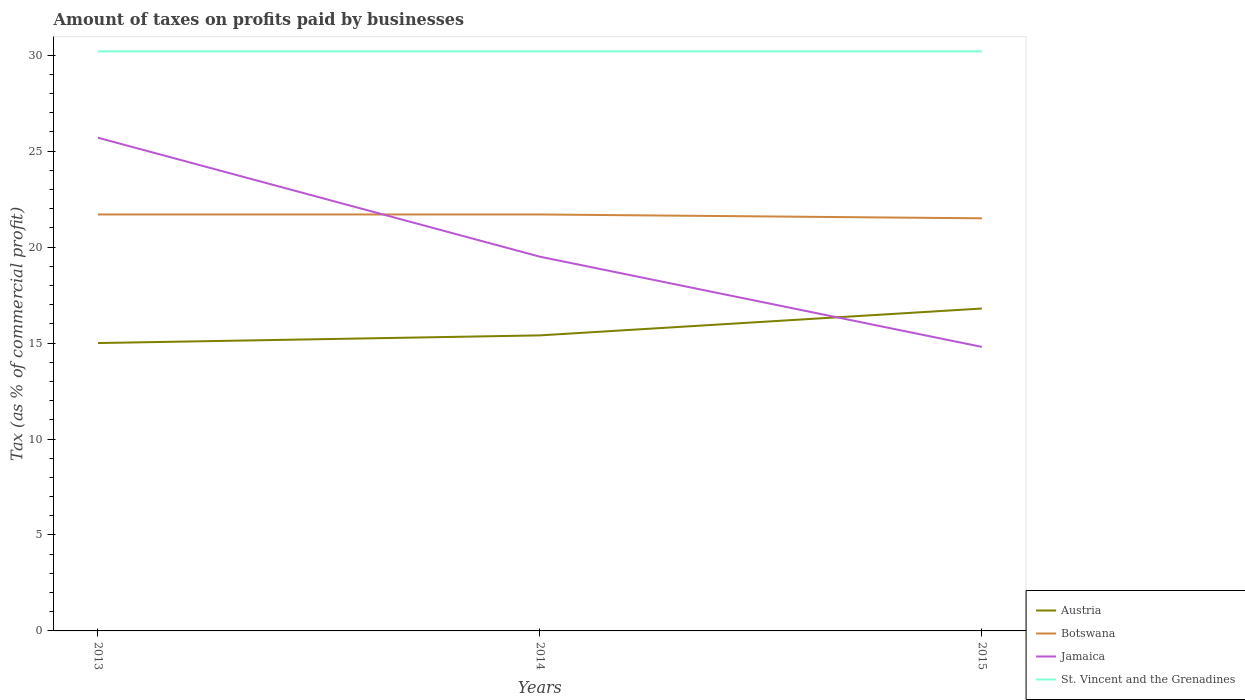Does the line corresponding to St. Vincent and the Grenadines intersect with the line corresponding to Botswana?
Make the answer very short. No. Across all years, what is the maximum percentage of taxes paid by businesses in St. Vincent and the Grenadines?
Give a very brief answer. 30.2. What is the total percentage of taxes paid by businesses in Jamaica in the graph?
Provide a succinct answer. 6.2. What is the difference between the highest and the second highest percentage of taxes paid by businesses in St. Vincent and the Grenadines?
Make the answer very short. 0. What is the difference between the highest and the lowest percentage of taxes paid by businesses in Austria?
Make the answer very short. 1. How many lines are there?
Make the answer very short. 4. How many years are there in the graph?
Make the answer very short. 3. Are the values on the major ticks of Y-axis written in scientific E-notation?
Give a very brief answer. No. Does the graph contain grids?
Give a very brief answer. No. Where does the legend appear in the graph?
Offer a very short reply. Bottom right. How many legend labels are there?
Ensure brevity in your answer.  4. How are the legend labels stacked?
Ensure brevity in your answer.  Vertical. What is the title of the graph?
Your answer should be compact. Amount of taxes on profits paid by businesses. Does "Togo" appear as one of the legend labels in the graph?
Your answer should be compact. No. What is the label or title of the X-axis?
Make the answer very short. Years. What is the label or title of the Y-axis?
Offer a terse response. Tax (as % of commercial profit). What is the Tax (as % of commercial profit) in Botswana in 2013?
Ensure brevity in your answer.  21.7. What is the Tax (as % of commercial profit) in Jamaica in 2013?
Ensure brevity in your answer.  25.7. What is the Tax (as % of commercial profit) in St. Vincent and the Grenadines in 2013?
Your response must be concise. 30.2. What is the Tax (as % of commercial profit) of Botswana in 2014?
Provide a short and direct response. 21.7. What is the Tax (as % of commercial profit) of St. Vincent and the Grenadines in 2014?
Provide a short and direct response. 30.2. What is the Tax (as % of commercial profit) in Austria in 2015?
Your answer should be very brief. 16.8. What is the Tax (as % of commercial profit) in Jamaica in 2015?
Make the answer very short. 14.8. What is the Tax (as % of commercial profit) in St. Vincent and the Grenadines in 2015?
Offer a terse response. 30.2. Across all years, what is the maximum Tax (as % of commercial profit) in Botswana?
Make the answer very short. 21.7. Across all years, what is the maximum Tax (as % of commercial profit) of Jamaica?
Give a very brief answer. 25.7. Across all years, what is the maximum Tax (as % of commercial profit) in St. Vincent and the Grenadines?
Make the answer very short. 30.2. Across all years, what is the minimum Tax (as % of commercial profit) of Austria?
Your answer should be very brief. 15. Across all years, what is the minimum Tax (as % of commercial profit) of St. Vincent and the Grenadines?
Provide a succinct answer. 30.2. What is the total Tax (as % of commercial profit) in Austria in the graph?
Your response must be concise. 47.2. What is the total Tax (as % of commercial profit) in Botswana in the graph?
Make the answer very short. 64.9. What is the total Tax (as % of commercial profit) in Jamaica in the graph?
Your answer should be very brief. 60. What is the total Tax (as % of commercial profit) in St. Vincent and the Grenadines in the graph?
Keep it short and to the point. 90.6. What is the difference between the Tax (as % of commercial profit) of Austria in 2013 and that in 2014?
Your answer should be very brief. -0.4. What is the difference between the Tax (as % of commercial profit) in St. Vincent and the Grenadines in 2013 and that in 2014?
Offer a very short reply. 0. What is the difference between the Tax (as % of commercial profit) in Austria in 2013 and that in 2015?
Your response must be concise. -1.8. What is the difference between the Tax (as % of commercial profit) of Jamaica in 2013 and that in 2015?
Keep it short and to the point. 10.9. What is the difference between the Tax (as % of commercial profit) of St. Vincent and the Grenadines in 2013 and that in 2015?
Make the answer very short. 0. What is the difference between the Tax (as % of commercial profit) in Austria in 2014 and that in 2015?
Your answer should be compact. -1.4. What is the difference between the Tax (as % of commercial profit) of Botswana in 2014 and that in 2015?
Provide a short and direct response. 0.2. What is the difference between the Tax (as % of commercial profit) in Jamaica in 2014 and that in 2015?
Make the answer very short. 4.7. What is the difference between the Tax (as % of commercial profit) of St. Vincent and the Grenadines in 2014 and that in 2015?
Your answer should be very brief. 0. What is the difference between the Tax (as % of commercial profit) in Austria in 2013 and the Tax (as % of commercial profit) in Botswana in 2014?
Your response must be concise. -6.7. What is the difference between the Tax (as % of commercial profit) of Austria in 2013 and the Tax (as % of commercial profit) of Jamaica in 2014?
Your answer should be compact. -4.5. What is the difference between the Tax (as % of commercial profit) of Austria in 2013 and the Tax (as % of commercial profit) of St. Vincent and the Grenadines in 2014?
Offer a very short reply. -15.2. What is the difference between the Tax (as % of commercial profit) of Jamaica in 2013 and the Tax (as % of commercial profit) of St. Vincent and the Grenadines in 2014?
Make the answer very short. -4.5. What is the difference between the Tax (as % of commercial profit) of Austria in 2013 and the Tax (as % of commercial profit) of Botswana in 2015?
Offer a very short reply. -6.5. What is the difference between the Tax (as % of commercial profit) in Austria in 2013 and the Tax (as % of commercial profit) in Jamaica in 2015?
Offer a very short reply. 0.2. What is the difference between the Tax (as % of commercial profit) in Austria in 2013 and the Tax (as % of commercial profit) in St. Vincent and the Grenadines in 2015?
Provide a short and direct response. -15.2. What is the difference between the Tax (as % of commercial profit) in Austria in 2014 and the Tax (as % of commercial profit) in St. Vincent and the Grenadines in 2015?
Make the answer very short. -14.8. What is the difference between the Tax (as % of commercial profit) of Botswana in 2014 and the Tax (as % of commercial profit) of Jamaica in 2015?
Your answer should be compact. 6.9. What is the average Tax (as % of commercial profit) of Austria per year?
Give a very brief answer. 15.73. What is the average Tax (as % of commercial profit) of Botswana per year?
Your answer should be very brief. 21.63. What is the average Tax (as % of commercial profit) of St. Vincent and the Grenadines per year?
Keep it short and to the point. 30.2. In the year 2013, what is the difference between the Tax (as % of commercial profit) of Austria and Tax (as % of commercial profit) of Botswana?
Ensure brevity in your answer.  -6.7. In the year 2013, what is the difference between the Tax (as % of commercial profit) in Austria and Tax (as % of commercial profit) in St. Vincent and the Grenadines?
Your answer should be very brief. -15.2. In the year 2013, what is the difference between the Tax (as % of commercial profit) in Botswana and Tax (as % of commercial profit) in St. Vincent and the Grenadines?
Ensure brevity in your answer.  -8.5. In the year 2013, what is the difference between the Tax (as % of commercial profit) in Jamaica and Tax (as % of commercial profit) in St. Vincent and the Grenadines?
Your answer should be compact. -4.5. In the year 2014, what is the difference between the Tax (as % of commercial profit) in Austria and Tax (as % of commercial profit) in Jamaica?
Your answer should be compact. -4.1. In the year 2014, what is the difference between the Tax (as % of commercial profit) in Austria and Tax (as % of commercial profit) in St. Vincent and the Grenadines?
Provide a succinct answer. -14.8. In the year 2014, what is the difference between the Tax (as % of commercial profit) of Botswana and Tax (as % of commercial profit) of Jamaica?
Make the answer very short. 2.2. In the year 2014, what is the difference between the Tax (as % of commercial profit) of Botswana and Tax (as % of commercial profit) of St. Vincent and the Grenadines?
Give a very brief answer. -8.5. In the year 2014, what is the difference between the Tax (as % of commercial profit) of Jamaica and Tax (as % of commercial profit) of St. Vincent and the Grenadines?
Your response must be concise. -10.7. In the year 2015, what is the difference between the Tax (as % of commercial profit) in Austria and Tax (as % of commercial profit) in Botswana?
Provide a succinct answer. -4.7. In the year 2015, what is the difference between the Tax (as % of commercial profit) in Austria and Tax (as % of commercial profit) in St. Vincent and the Grenadines?
Keep it short and to the point. -13.4. In the year 2015, what is the difference between the Tax (as % of commercial profit) in Jamaica and Tax (as % of commercial profit) in St. Vincent and the Grenadines?
Ensure brevity in your answer.  -15.4. What is the ratio of the Tax (as % of commercial profit) in Austria in 2013 to that in 2014?
Your response must be concise. 0.97. What is the ratio of the Tax (as % of commercial profit) of Botswana in 2013 to that in 2014?
Your answer should be compact. 1. What is the ratio of the Tax (as % of commercial profit) of Jamaica in 2013 to that in 2014?
Keep it short and to the point. 1.32. What is the ratio of the Tax (as % of commercial profit) in Austria in 2013 to that in 2015?
Your answer should be very brief. 0.89. What is the ratio of the Tax (as % of commercial profit) of Botswana in 2013 to that in 2015?
Keep it short and to the point. 1.01. What is the ratio of the Tax (as % of commercial profit) in Jamaica in 2013 to that in 2015?
Your response must be concise. 1.74. What is the ratio of the Tax (as % of commercial profit) in St. Vincent and the Grenadines in 2013 to that in 2015?
Make the answer very short. 1. What is the ratio of the Tax (as % of commercial profit) in Botswana in 2014 to that in 2015?
Your answer should be compact. 1.01. What is the ratio of the Tax (as % of commercial profit) in Jamaica in 2014 to that in 2015?
Your answer should be compact. 1.32. What is the ratio of the Tax (as % of commercial profit) of St. Vincent and the Grenadines in 2014 to that in 2015?
Your answer should be compact. 1. What is the difference between the highest and the second highest Tax (as % of commercial profit) of Austria?
Your answer should be very brief. 1.4. What is the difference between the highest and the second highest Tax (as % of commercial profit) in Jamaica?
Offer a terse response. 6.2. What is the difference between the highest and the second highest Tax (as % of commercial profit) in St. Vincent and the Grenadines?
Your answer should be compact. 0. What is the difference between the highest and the lowest Tax (as % of commercial profit) of Jamaica?
Your answer should be compact. 10.9. 